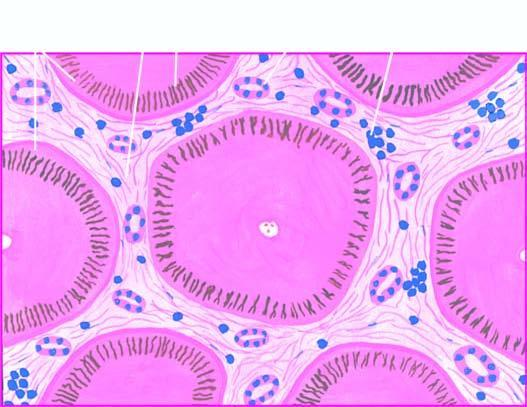what are there dividing the hepatic parenchyma into the micronodules?
Answer the question using a single word or phrase. Fibrous scars 